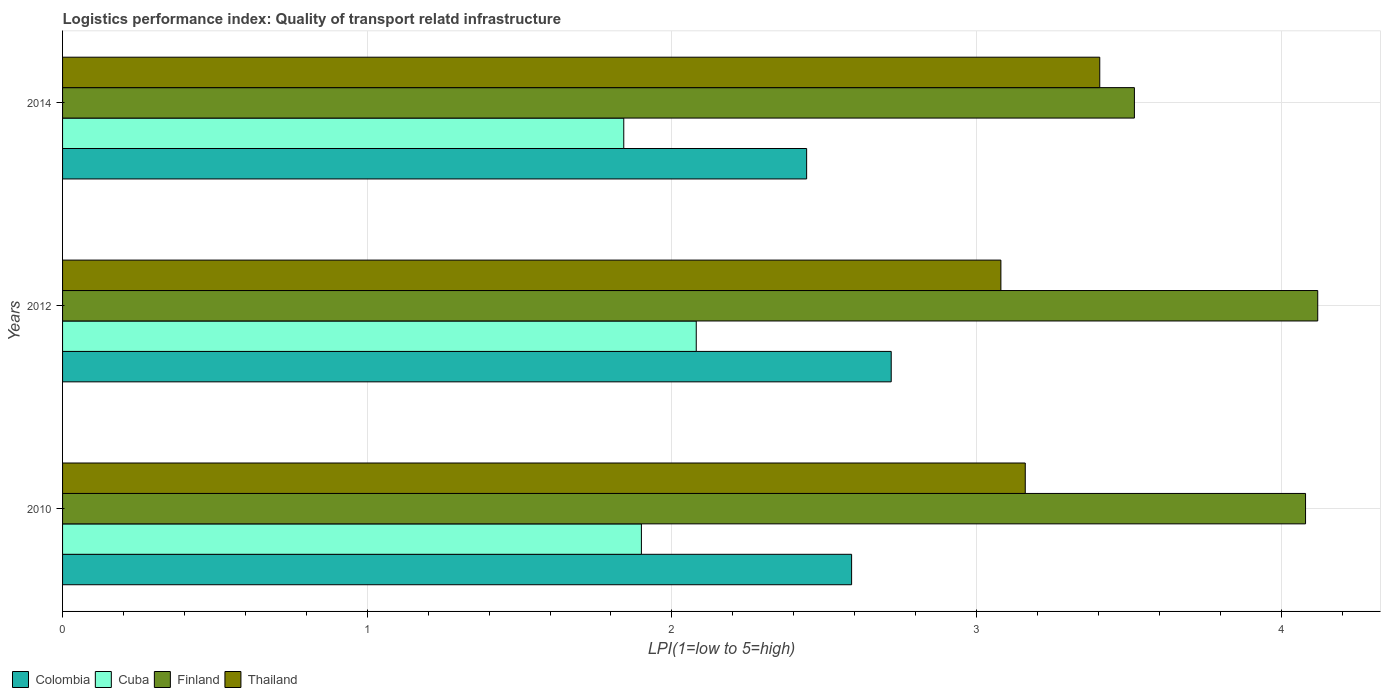How many different coloured bars are there?
Your response must be concise. 4. How many bars are there on the 3rd tick from the top?
Ensure brevity in your answer.  4. What is the label of the 1st group of bars from the top?
Your answer should be compact. 2014. In how many cases, is the number of bars for a given year not equal to the number of legend labels?
Your answer should be compact. 0. What is the logistics performance index in Finland in 2010?
Your response must be concise. 4.08. Across all years, what is the maximum logistics performance index in Thailand?
Your response must be concise. 3.4. Across all years, what is the minimum logistics performance index in Cuba?
Provide a short and direct response. 1.84. In which year was the logistics performance index in Finland minimum?
Your answer should be very brief. 2014. What is the total logistics performance index in Finland in the graph?
Ensure brevity in your answer.  11.72. What is the difference between the logistics performance index in Thailand in 2010 and that in 2014?
Keep it short and to the point. -0.24. What is the difference between the logistics performance index in Cuba in 2010 and the logistics performance index in Finland in 2012?
Ensure brevity in your answer.  -2.22. What is the average logistics performance index in Finland per year?
Offer a terse response. 3.91. In the year 2014, what is the difference between the logistics performance index in Finland and logistics performance index in Thailand?
Ensure brevity in your answer.  0.11. What is the ratio of the logistics performance index in Finland in 2010 to that in 2012?
Make the answer very short. 0.99. What is the difference between the highest and the second highest logistics performance index in Finland?
Keep it short and to the point. 0.04. What is the difference between the highest and the lowest logistics performance index in Colombia?
Offer a terse response. 0.28. Is the sum of the logistics performance index in Thailand in 2010 and 2014 greater than the maximum logistics performance index in Cuba across all years?
Your answer should be compact. Yes. Is it the case that in every year, the sum of the logistics performance index in Thailand and logistics performance index in Finland is greater than the sum of logistics performance index in Colombia and logistics performance index in Cuba?
Your response must be concise. Yes. What does the 3rd bar from the top in 2010 represents?
Ensure brevity in your answer.  Cuba. What does the 4th bar from the bottom in 2014 represents?
Provide a short and direct response. Thailand. Are all the bars in the graph horizontal?
Offer a very short reply. Yes. Does the graph contain grids?
Provide a succinct answer. Yes. How are the legend labels stacked?
Keep it short and to the point. Horizontal. What is the title of the graph?
Your answer should be very brief. Logistics performance index: Quality of transport relatd infrastructure. What is the label or title of the X-axis?
Keep it short and to the point. LPI(1=low to 5=high). What is the label or title of the Y-axis?
Your answer should be compact. Years. What is the LPI(1=low to 5=high) of Colombia in 2010?
Ensure brevity in your answer.  2.59. What is the LPI(1=low to 5=high) in Cuba in 2010?
Offer a terse response. 1.9. What is the LPI(1=low to 5=high) in Finland in 2010?
Your answer should be compact. 4.08. What is the LPI(1=low to 5=high) of Thailand in 2010?
Provide a short and direct response. 3.16. What is the LPI(1=low to 5=high) of Colombia in 2012?
Provide a succinct answer. 2.72. What is the LPI(1=low to 5=high) in Cuba in 2012?
Ensure brevity in your answer.  2.08. What is the LPI(1=low to 5=high) in Finland in 2012?
Offer a very short reply. 4.12. What is the LPI(1=low to 5=high) in Thailand in 2012?
Offer a terse response. 3.08. What is the LPI(1=low to 5=high) in Colombia in 2014?
Provide a short and direct response. 2.44. What is the LPI(1=low to 5=high) of Cuba in 2014?
Provide a short and direct response. 1.84. What is the LPI(1=low to 5=high) of Finland in 2014?
Keep it short and to the point. 3.52. What is the LPI(1=low to 5=high) in Thailand in 2014?
Offer a very short reply. 3.4. Across all years, what is the maximum LPI(1=low to 5=high) of Colombia?
Provide a succinct answer. 2.72. Across all years, what is the maximum LPI(1=low to 5=high) of Cuba?
Offer a very short reply. 2.08. Across all years, what is the maximum LPI(1=low to 5=high) in Finland?
Your answer should be very brief. 4.12. Across all years, what is the maximum LPI(1=low to 5=high) of Thailand?
Give a very brief answer. 3.4. Across all years, what is the minimum LPI(1=low to 5=high) of Colombia?
Ensure brevity in your answer.  2.44. Across all years, what is the minimum LPI(1=low to 5=high) of Cuba?
Keep it short and to the point. 1.84. Across all years, what is the minimum LPI(1=low to 5=high) of Finland?
Your response must be concise. 3.52. Across all years, what is the minimum LPI(1=low to 5=high) of Thailand?
Ensure brevity in your answer.  3.08. What is the total LPI(1=low to 5=high) in Colombia in the graph?
Keep it short and to the point. 7.75. What is the total LPI(1=low to 5=high) in Cuba in the graph?
Provide a short and direct response. 5.82. What is the total LPI(1=low to 5=high) in Finland in the graph?
Your response must be concise. 11.72. What is the total LPI(1=low to 5=high) of Thailand in the graph?
Your response must be concise. 9.64. What is the difference between the LPI(1=low to 5=high) in Colombia in 2010 and that in 2012?
Make the answer very short. -0.13. What is the difference between the LPI(1=low to 5=high) in Cuba in 2010 and that in 2012?
Your response must be concise. -0.18. What is the difference between the LPI(1=low to 5=high) of Finland in 2010 and that in 2012?
Ensure brevity in your answer.  -0.04. What is the difference between the LPI(1=low to 5=high) of Thailand in 2010 and that in 2012?
Ensure brevity in your answer.  0.08. What is the difference between the LPI(1=low to 5=high) in Colombia in 2010 and that in 2014?
Your answer should be very brief. 0.15. What is the difference between the LPI(1=low to 5=high) in Cuba in 2010 and that in 2014?
Offer a terse response. 0.06. What is the difference between the LPI(1=low to 5=high) in Finland in 2010 and that in 2014?
Offer a very short reply. 0.56. What is the difference between the LPI(1=low to 5=high) of Thailand in 2010 and that in 2014?
Your answer should be very brief. -0.24. What is the difference between the LPI(1=low to 5=high) in Colombia in 2012 and that in 2014?
Provide a succinct answer. 0.28. What is the difference between the LPI(1=low to 5=high) in Cuba in 2012 and that in 2014?
Keep it short and to the point. 0.24. What is the difference between the LPI(1=low to 5=high) of Finland in 2012 and that in 2014?
Keep it short and to the point. 0.6. What is the difference between the LPI(1=low to 5=high) in Thailand in 2012 and that in 2014?
Your response must be concise. -0.32. What is the difference between the LPI(1=low to 5=high) of Colombia in 2010 and the LPI(1=low to 5=high) of Cuba in 2012?
Your answer should be compact. 0.51. What is the difference between the LPI(1=low to 5=high) in Colombia in 2010 and the LPI(1=low to 5=high) in Finland in 2012?
Your answer should be very brief. -1.53. What is the difference between the LPI(1=low to 5=high) in Colombia in 2010 and the LPI(1=low to 5=high) in Thailand in 2012?
Give a very brief answer. -0.49. What is the difference between the LPI(1=low to 5=high) in Cuba in 2010 and the LPI(1=low to 5=high) in Finland in 2012?
Provide a succinct answer. -2.22. What is the difference between the LPI(1=low to 5=high) in Cuba in 2010 and the LPI(1=low to 5=high) in Thailand in 2012?
Your response must be concise. -1.18. What is the difference between the LPI(1=low to 5=high) of Finland in 2010 and the LPI(1=low to 5=high) of Thailand in 2012?
Provide a succinct answer. 1. What is the difference between the LPI(1=low to 5=high) of Colombia in 2010 and the LPI(1=low to 5=high) of Cuba in 2014?
Ensure brevity in your answer.  0.75. What is the difference between the LPI(1=low to 5=high) in Colombia in 2010 and the LPI(1=low to 5=high) in Finland in 2014?
Ensure brevity in your answer.  -0.93. What is the difference between the LPI(1=low to 5=high) of Colombia in 2010 and the LPI(1=low to 5=high) of Thailand in 2014?
Ensure brevity in your answer.  -0.81. What is the difference between the LPI(1=low to 5=high) in Cuba in 2010 and the LPI(1=low to 5=high) in Finland in 2014?
Offer a terse response. -1.62. What is the difference between the LPI(1=low to 5=high) of Cuba in 2010 and the LPI(1=low to 5=high) of Thailand in 2014?
Make the answer very short. -1.5. What is the difference between the LPI(1=low to 5=high) of Finland in 2010 and the LPI(1=low to 5=high) of Thailand in 2014?
Give a very brief answer. 0.68. What is the difference between the LPI(1=low to 5=high) in Colombia in 2012 and the LPI(1=low to 5=high) in Cuba in 2014?
Make the answer very short. 0.88. What is the difference between the LPI(1=low to 5=high) in Colombia in 2012 and the LPI(1=low to 5=high) in Finland in 2014?
Give a very brief answer. -0.8. What is the difference between the LPI(1=low to 5=high) in Colombia in 2012 and the LPI(1=low to 5=high) in Thailand in 2014?
Offer a very short reply. -0.68. What is the difference between the LPI(1=low to 5=high) of Cuba in 2012 and the LPI(1=low to 5=high) of Finland in 2014?
Offer a terse response. -1.44. What is the difference between the LPI(1=low to 5=high) of Cuba in 2012 and the LPI(1=low to 5=high) of Thailand in 2014?
Ensure brevity in your answer.  -1.32. What is the difference between the LPI(1=low to 5=high) of Finland in 2012 and the LPI(1=low to 5=high) of Thailand in 2014?
Offer a very short reply. 0.72. What is the average LPI(1=low to 5=high) in Colombia per year?
Provide a short and direct response. 2.58. What is the average LPI(1=low to 5=high) of Cuba per year?
Offer a very short reply. 1.94. What is the average LPI(1=low to 5=high) in Finland per year?
Provide a succinct answer. 3.91. What is the average LPI(1=low to 5=high) in Thailand per year?
Make the answer very short. 3.21. In the year 2010, what is the difference between the LPI(1=low to 5=high) of Colombia and LPI(1=low to 5=high) of Cuba?
Make the answer very short. 0.69. In the year 2010, what is the difference between the LPI(1=low to 5=high) in Colombia and LPI(1=low to 5=high) in Finland?
Make the answer very short. -1.49. In the year 2010, what is the difference between the LPI(1=low to 5=high) of Colombia and LPI(1=low to 5=high) of Thailand?
Offer a very short reply. -0.57. In the year 2010, what is the difference between the LPI(1=low to 5=high) of Cuba and LPI(1=low to 5=high) of Finland?
Provide a succinct answer. -2.18. In the year 2010, what is the difference between the LPI(1=low to 5=high) of Cuba and LPI(1=low to 5=high) of Thailand?
Offer a terse response. -1.26. In the year 2012, what is the difference between the LPI(1=low to 5=high) of Colombia and LPI(1=low to 5=high) of Cuba?
Provide a short and direct response. 0.64. In the year 2012, what is the difference between the LPI(1=low to 5=high) of Colombia and LPI(1=low to 5=high) of Thailand?
Your response must be concise. -0.36. In the year 2012, what is the difference between the LPI(1=low to 5=high) in Cuba and LPI(1=low to 5=high) in Finland?
Keep it short and to the point. -2.04. In the year 2014, what is the difference between the LPI(1=low to 5=high) in Colombia and LPI(1=low to 5=high) in Cuba?
Ensure brevity in your answer.  0.6. In the year 2014, what is the difference between the LPI(1=low to 5=high) in Colombia and LPI(1=low to 5=high) in Finland?
Provide a short and direct response. -1.08. In the year 2014, what is the difference between the LPI(1=low to 5=high) of Colombia and LPI(1=low to 5=high) of Thailand?
Make the answer very short. -0.96. In the year 2014, what is the difference between the LPI(1=low to 5=high) in Cuba and LPI(1=low to 5=high) in Finland?
Your answer should be very brief. -1.68. In the year 2014, what is the difference between the LPI(1=low to 5=high) of Cuba and LPI(1=low to 5=high) of Thailand?
Give a very brief answer. -1.56. In the year 2014, what is the difference between the LPI(1=low to 5=high) in Finland and LPI(1=low to 5=high) in Thailand?
Make the answer very short. 0.11. What is the ratio of the LPI(1=low to 5=high) in Colombia in 2010 to that in 2012?
Your answer should be compact. 0.95. What is the ratio of the LPI(1=low to 5=high) of Cuba in 2010 to that in 2012?
Your answer should be compact. 0.91. What is the ratio of the LPI(1=low to 5=high) of Finland in 2010 to that in 2012?
Your answer should be compact. 0.99. What is the ratio of the LPI(1=low to 5=high) of Colombia in 2010 to that in 2014?
Ensure brevity in your answer.  1.06. What is the ratio of the LPI(1=low to 5=high) in Cuba in 2010 to that in 2014?
Provide a short and direct response. 1.03. What is the ratio of the LPI(1=low to 5=high) in Finland in 2010 to that in 2014?
Provide a short and direct response. 1.16. What is the ratio of the LPI(1=low to 5=high) in Thailand in 2010 to that in 2014?
Offer a very short reply. 0.93. What is the ratio of the LPI(1=low to 5=high) in Colombia in 2012 to that in 2014?
Offer a very short reply. 1.11. What is the ratio of the LPI(1=low to 5=high) of Cuba in 2012 to that in 2014?
Offer a very short reply. 1.13. What is the ratio of the LPI(1=low to 5=high) in Finland in 2012 to that in 2014?
Offer a very short reply. 1.17. What is the ratio of the LPI(1=low to 5=high) in Thailand in 2012 to that in 2014?
Your response must be concise. 0.9. What is the difference between the highest and the second highest LPI(1=low to 5=high) in Colombia?
Ensure brevity in your answer.  0.13. What is the difference between the highest and the second highest LPI(1=low to 5=high) of Cuba?
Make the answer very short. 0.18. What is the difference between the highest and the second highest LPI(1=low to 5=high) of Thailand?
Give a very brief answer. 0.24. What is the difference between the highest and the lowest LPI(1=low to 5=high) of Colombia?
Give a very brief answer. 0.28. What is the difference between the highest and the lowest LPI(1=low to 5=high) in Cuba?
Offer a terse response. 0.24. What is the difference between the highest and the lowest LPI(1=low to 5=high) of Finland?
Your answer should be very brief. 0.6. What is the difference between the highest and the lowest LPI(1=low to 5=high) in Thailand?
Ensure brevity in your answer.  0.32. 